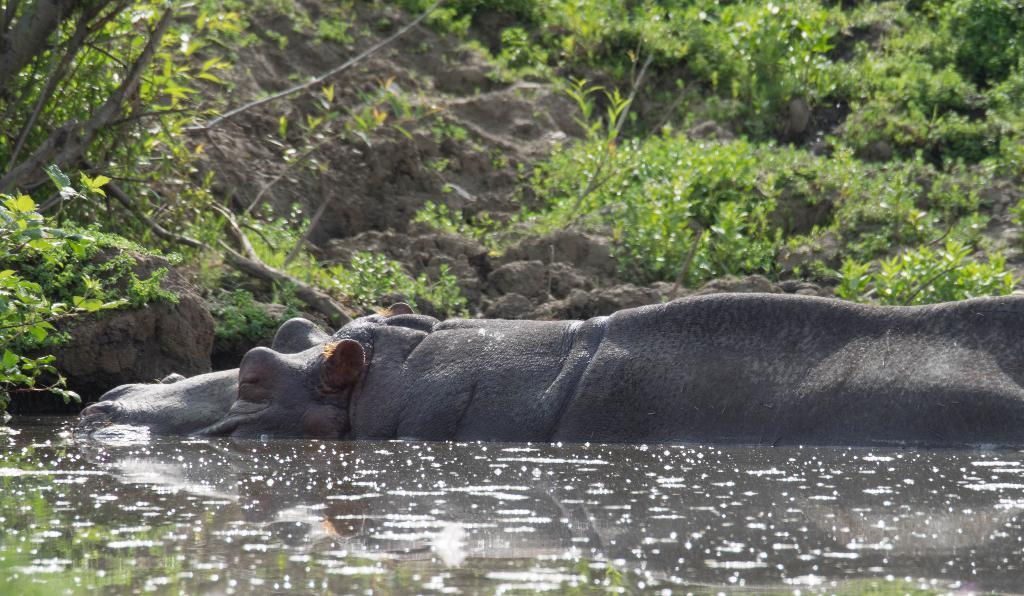What is the main element present in the image? There is water in the image. What animal can be seen in the water? A part of a hippopotamus is visible in the water. What is the color of the hippopotamus? The hippopotamus is gray in color. What other objects or features can be seen in the image? There are rocks and plants visible in the image. What is the rate at which the bell is ringing in the image? There is no bell present in the image, so it is not possible to determine the rate at which it might be ringing. 